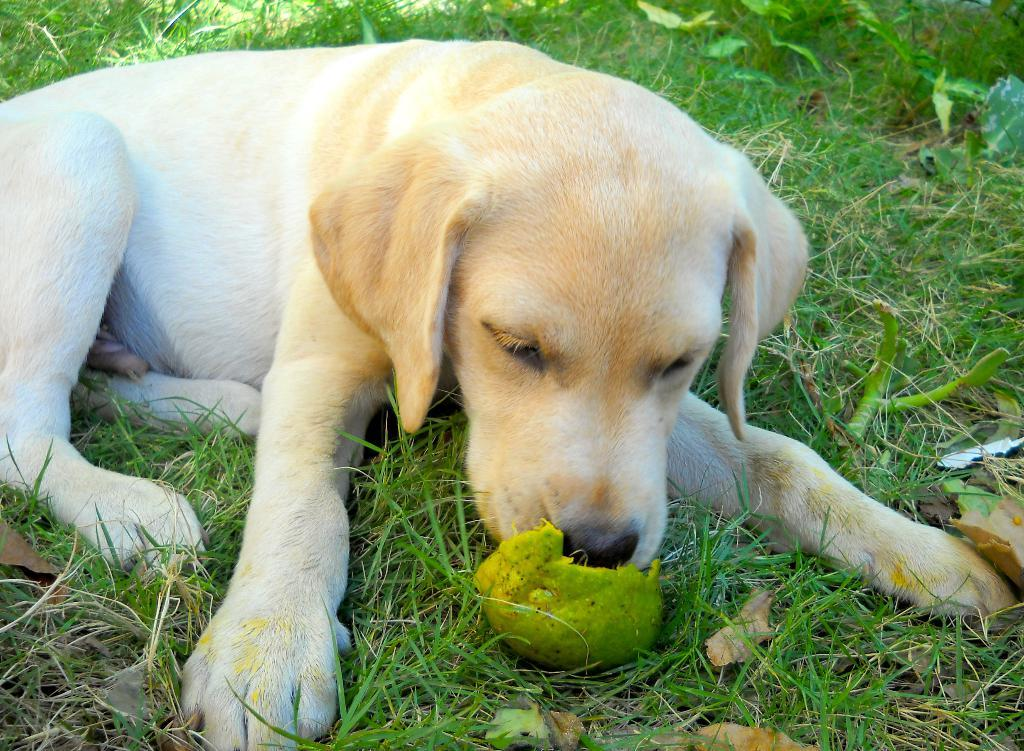What animal can be seen on the ground in the image? There is a dog on the ground in the image. What type of terrain is visible in the image? There is grass visible in the image. What type of food is present in the image? There is a fruit in the image. What type of vegetation is present in the image? There are plants in the image. What type of pizzas are being discussed in the argument in the image? There is no argument or pizzas present in the image; it features a dog, grass, fruit, and plants. 